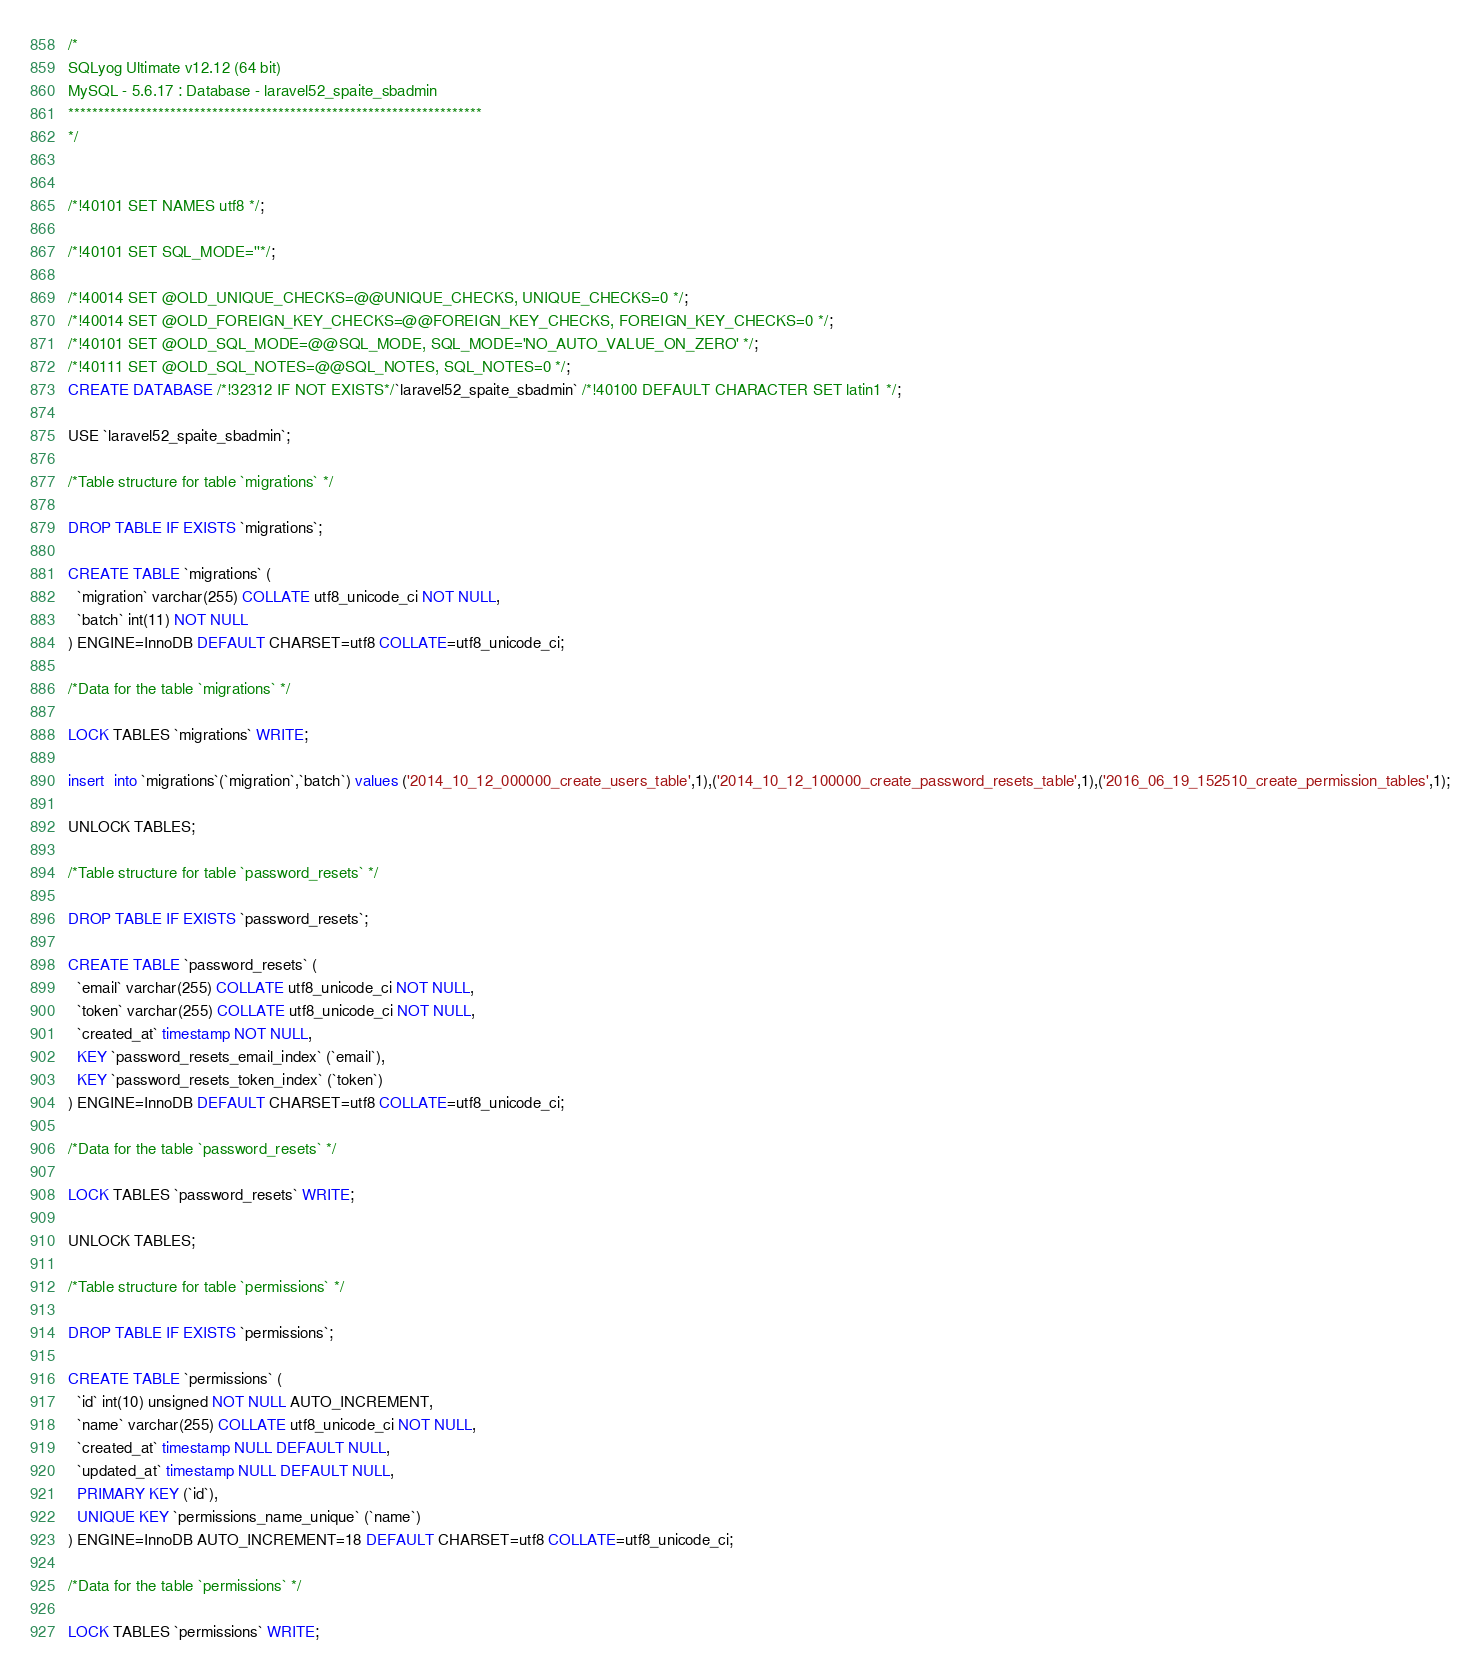<code> <loc_0><loc_0><loc_500><loc_500><_SQL_>/*
SQLyog Ultimate v12.12 (64 bit)
MySQL - 5.6.17 : Database - laravel52_spaite_sbadmin
*********************************************************************
*/

/*!40101 SET NAMES utf8 */;

/*!40101 SET SQL_MODE=''*/;

/*!40014 SET @OLD_UNIQUE_CHECKS=@@UNIQUE_CHECKS, UNIQUE_CHECKS=0 */;
/*!40014 SET @OLD_FOREIGN_KEY_CHECKS=@@FOREIGN_KEY_CHECKS, FOREIGN_KEY_CHECKS=0 */;
/*!40101 SET @OLD_SQL_MODE=@@SQL_MODE, SQL_MODE='NO_AUTO_VALUE_ON_ZERO' */;
/*!40111 SET @OLD_SQL_NOTES=@@SQL_NOTES, SQL_NOTES=0 */;
CREATE DATABASE /*!32312 IF NOT EXISTS*/`laravel52_spaite_sbadmin` /*!40100 DEFAULT CHARACTER SET latin1 */;

USE `laravel52_spaite_sbadmin`;

/*Table structure for table `migrations` */

DROP TABLE IF EXISTS `migrations`;

CREATE TABLE `migrations` (
  `migration` varchar(255) COLLATE utf8_unicode_ci NOT NULL,
  `batch` int(11) NOT NULL
) ENGINE=InnoDB DEFAULT CHARSET=utf8 COLLATE=utf8_unicode_ci;

/*Data for the table `migrations` */

LOCK TABLES `migrations` WRITE;

insert  into `migrations`(`migration`,`batch`) values ('2014_10_12_000000_create_users_table',1),('2014_10_12_100000_create_password_resets_table',1),('2016_06_19_152510_create_permission_tables',1);

UNLOCK TABLES;

/*Table structure for table `password_resets` */

DROP TABLE IF EXISTS `password_resets`;

CREATE TABLE `password_resets` (
  `email` varchar(255) COLLATE utf8_unicode_ci NOT NULL,
  `token` varchar(255) COLLATE utf8_unicode_ci NOT NULL,
  `created_at` timestamp NOT NULL,
  KEY `password_resets_email_index` (`email`),
  KEY `password_resets_token_index` (`token`)
) ENGINE=InnoDB DEFAULT CHARSET=utf8 COLLATE=utf8_unicode_ci;

/*Data for the table `password_resets` */

LOCK TABLES `password_resets` WRITE;

UNLOCK TABLES;

/*Table structure for table `permissions` */

DROP TABLE IF EXISTS `permissions`;

CREATE TABLE `permissions` (
  `id` int(10) unsigned NOT NULL AUTO_INCREMENT,
  `name` varchar(255) COLLATE utf8_unicode_ci NOT NULL,
  `created_at` timestamp NULL DEFAULT NULL,
  `updated_at` timestamp NULL DEFAULT NULL,
  PRIMARY KEY (`id`),
  UNIQUE KEY `permissions_name_unique` (`name`)
) ENGINE=InnoDB AUTO_INCREMENT=18 DEFAULT CHARSET=utf8 COLLATE=utf8_unicode_ci;

/*Data for the table `permissions` */

LOCK TABLES `permissions` WRITE;
</code> 